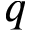Convert formula to latex. <formula><loc_0><loc_0><loc_500><loc_500>q</formula> 